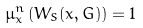Convert formula to latex. <formula><loc_0><loc_0><loc_500><loc_500>\mu ^ { n } _ { x } \left ( W _ { S } ( x , G ) \right ) = 1</formula> 